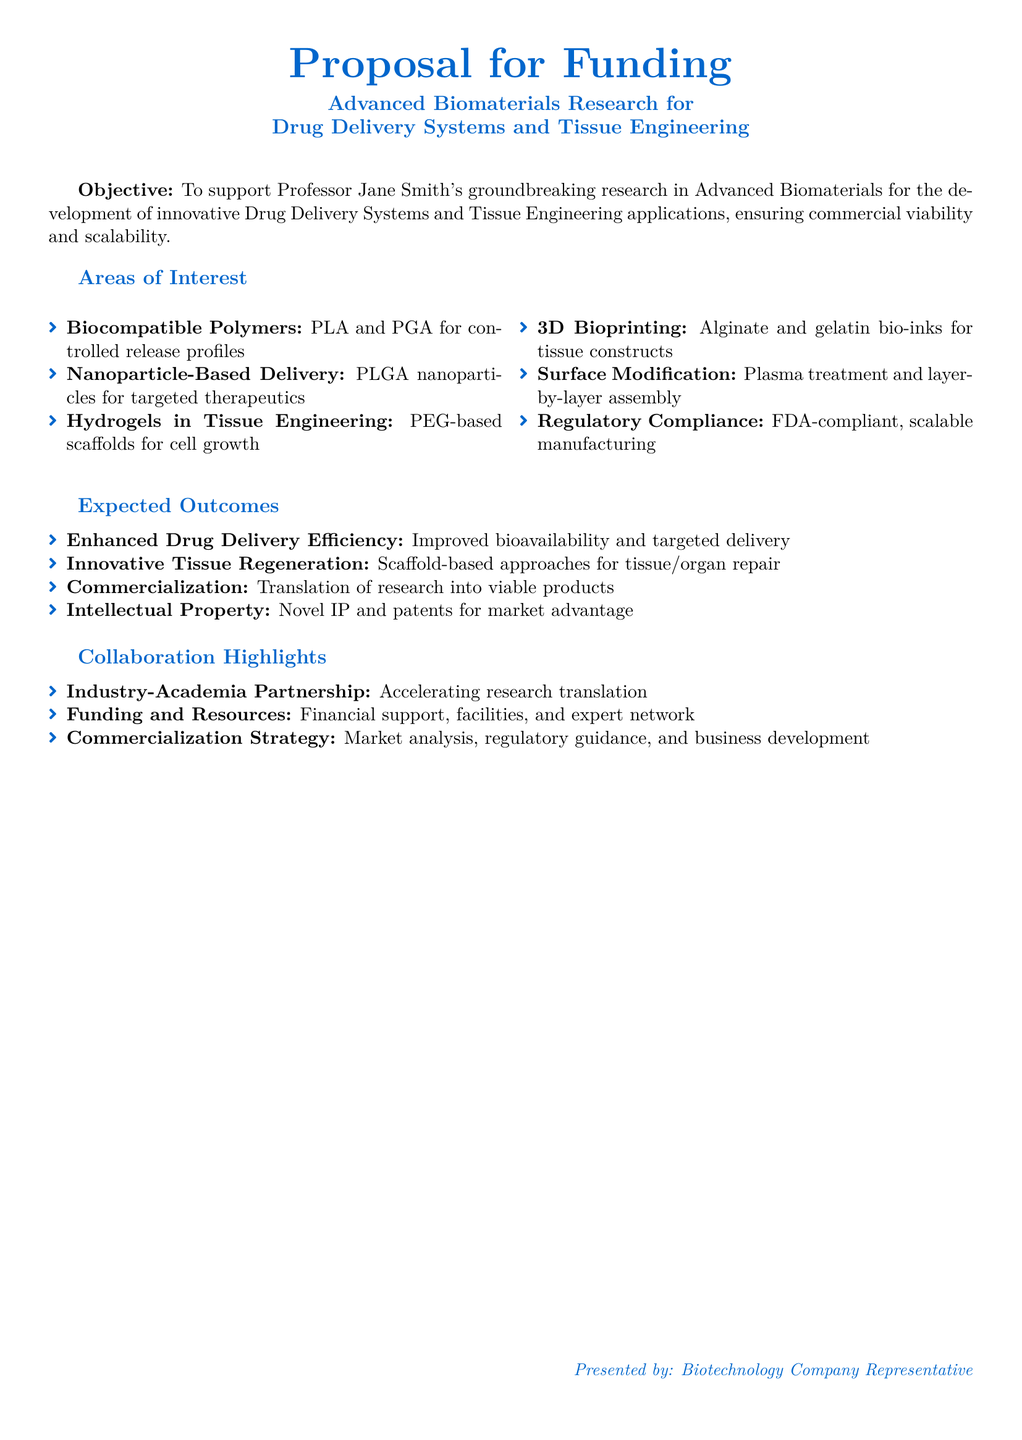What is the title of the proposal? The title of the proposal is found in the header section stating the focus of the research.
Answer: Proposal for Funding Who is the principal investigator mentioned in the proposal? The principal investigator is identified in the objective section of the proposal.
Answer: Professor Jane Smith What type of polymers are discussed for controlled release profiles? The specific types of polymers are listed under the areas of interest in the proposal.
Answer: PLA and PGA What is one of the expected outcomes related to tissue regeneration? This information is found in the expected outcomes section, indicating the goals of the research.
Answer: Scaffold-based approaches for tissue/organ repair What method is proposed for enhancing drug delivery efficiency? This detail can be found in the expected outcomes that focus on the benefits of the research.
Answer: Improved bioavailability and targeted delivery What strategy is highlighted for commercialization in the collaboration? The document lists this aspect in the collaboration highlights section.
Answer: Market analysis, regulatory guidance, and business development 